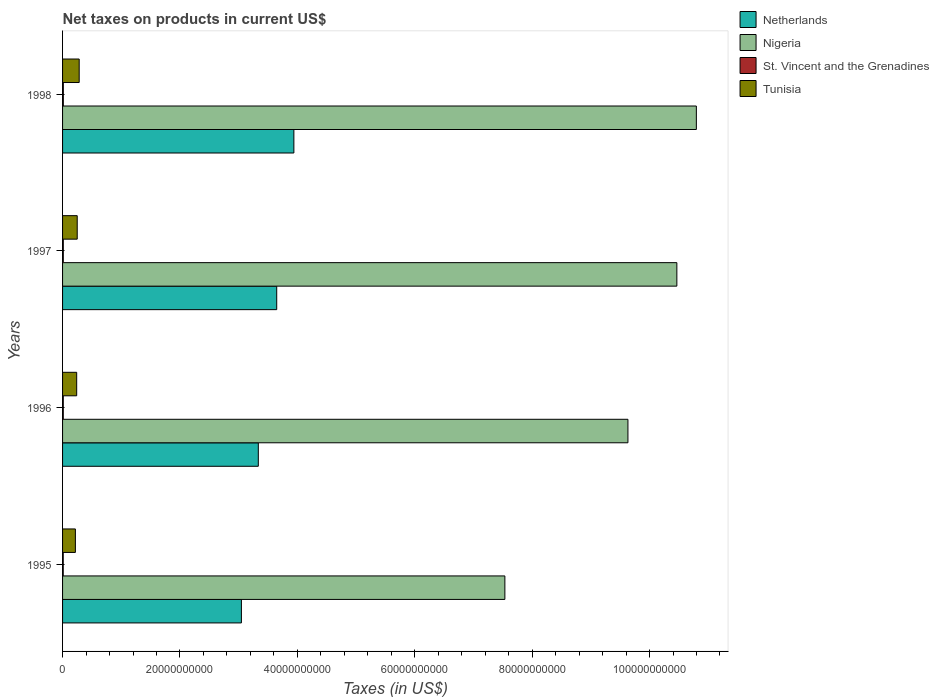How many different coloured bars are there?
Ensure brevity in your answer.  4. How many groups of bars are there?
Ensure brevity in your answer.  4. Are the number of bars per tick equal to the number of legend labels?
Provide a short and direct response. Yes. Are the number of bars on each tick of the Y-axis equal?
Your answer should be very brief. Yes. How many bars are there on the 1st tick from the bottom?
Your answer should be very brief. 4. In how many cases, is the number of bars for a given year not equal to the number of legend labels?
Keep it short and to the point. 0. What is the net taxes on products in Tunisia in 1997?
Make the answer very short. 2.50e+09. Across all years, what is the maximum net taxes on products in St. Vincent and the Grenadines?
Provide a succinct answer. 1.31e+08. Across all years, what is the minimum net taxes on products in Nigeria?
Offer a terse response. 7.54e+1. What is the total net taxes on products in Netherlands in the graph?
Keep it short and to the point. 1.40e+11. What is the difference between the net taxes on products in Tunisia in 1996 and that in 1997?
Keep it short and to the point. -9.08e+07. What is the difference between the net taxes on products in Nigeria in 1995 and the net taxes on products in St. Vincent and the Grenadines in 1997?
Your response must be concise. 7.52e+1. What is the average net taxes on products in Nigeria per year?
Make the answer very short. 9.61e+1. In the year 1995, what is the difference between the net taxes on products in Nigeria and net taxes on products in St. Vincent and the Grenadines?
Make the answer very short. 7.52e+1. In how many years, is the net taxes on products in St. Vincent and the Grenadines greater than 40000000000 US$?
Provide a short and direct response. 0. What is the ratio of the net taxes on products in Tunisia in 1995 to that in 1996?
Make the answer very short. 0.91. What is the difference between the highest and the second highest net taxes on products in Tunisia?
Your answer should be compact. 3.37e+08. What is the difference between the highest and the lowest net taxes on products in Netherlands?
Give a very brief answer. 8.94e+09. Is the sum of the net taxes on products in Netherlands in 1995 and 1996 greater than the maximum net taxes on products in St. Vincent and the Grenadines across all years?
Provide a short and direct response. Yes. What does the 1st bar from the top in 1997 represents?
Make the answer very short. Tunisia. What does the 3rd bar from the bottom in 1998 represents?
Keep it short and to the point. St. Vincent and the Grenadines. Is it the case that in every year, the sum of the net taxes on products in Nigeria and net taxes on products in Tunisia is greater than the net taxes on products in Netherlands?
Keep it short and to the point. Yes. How many bars are there?
Keep it short and to the point. 16. What is the difference between two consecutive major ticks on the X-axis?
Give a very brief answer. 2.00e+1. Are the values on the major ticks of X-axis written in scientific E-notation?
Offer a very short reply. No. Where does the legend appear in the graph?
Provide a succinct answer. Top right. How many legend labels are there?
Keep it short and to the point. 4. What is the title of the graph?
Give a very brief answer. Net taxes on products in current US$. What is the label or title of the X-axis?
Offer a very short reply. Taxes (in US$). What is the label or title of the Y-axis?
Your answer should be very brief. Years. What is the Taxes (in US$) in Netherlands in 1995?
Offer a very short reply. 3.05e+1. What is the Taxes (in US$) of Nigeria in 1995?
Give a very brief answer. 7.54e+1. What is the Taxes (in US$) of St. Vincent and the Grenadines in 1995?
Offer a very short reply. 1.13e+08. What is the Taxes (in US$) of Tunisia in 1995?
Your answer should be very brief. 2.19e+09. What is the Taxes (in US$) in Netherlands in 1996?
Make the answer very short. 3.33e+1. What is the Taxes (in US$) of Nigeria in 1996?
Offer a very short reply. 9.63e+1. What is the Taxes (in US$) of St. Vincent and the Grenadines in 1996?
Make the answer very short. 1.21e+08. What is the Taxes (in US$) in Tunisia in 1996?
Offer a very short reply. 2.41e+09. What is the Taxes (in US$) in Netherlands in 1997?
Your answer should be compact. 3.65e+1. What is the Taxes (in US$) in Nigeria in 1997?
Make the answer very short. 1.05e+11. What is the Taxes (in US$) of St. Vincent and the Grenadines in 1997?
Provide a short and direct response. 1.25e+08. What is the Taxes (in US$) in Tunisia in 1997?
Make the answer very short. 2.50e+09. What is the Taxes (in US$) in Netherlands in 1998?
Offer a very short reply. 3.94e+1. What is the Taxes (in US$) of Nigeria in 1998?
Offer a terse response. 1.08e+11. What is the Taxes (in US$) of St. Vincent and the Grenadines in 1998?
Provide a short and direct response. 1.31e+08. What is the Taxes (in US$) in Tunisia in 1998?
Make the answer very short. 2.83e+09. Across all years, what is the maximum Taxes (in US$) in Netherlands?
Give a very brief answer. 3.94e+1. Across all years, what is the maximum Taxes (in US$) of Nigeria?
Offer a very short reply. 1.08e+11. Across all years, what is the maximum Taxes (in US$) of St. Vincent and the Grenadines?
Provide a succinct answer. 1.31e+08. Across all years, what is the maximum Taxes (in US$) of Tunisia?
Your answer should be very brief. 2.83e+09. Across all years, what is the minimum Taxes (in US$) in Netherlands?
Keep it short and to the point. 3.05e+1. Across all years, what is the minimum Taxes (in US$) in Nigeria?
Provide a succinct answer. 7.54e+1. Across all years, what is the minimum Taxes (in US$) in St. Vincent and the Grenadines?
Provide a succinct answer. 1.13e+08. Across all years, what is the minimum Taxes (in US$) of Tunisia?
Your answer should be compact. 2.19e+09. What is the total Taxes (in US$) in Netherlands in the graph?
Keep it short and to the point. 1.40e+11. What is the total Taxes (in US$) of Nigeria in the graph?
Provide a succinct answer. 3.84e+11. What is the total Taxes (in US$) in St. Vincent and the Grenadines in the graph?
Your answer should be compact. 4.90e+08. What is the total Taxes (in US$) of Tunisia in the graph?
Keep it short and to the point. 9.92e+09. What is the difference between the Taxes (in US$) in Netherlands in 1995 and that in 1996?
Your answer should be very brief. -2.88e+09. What is the difference between the Taxes (in US$) in Nigeria in 1995 and that in 1996?
Give a very brief answer. -2.10e+1. What is the difference between the Taxes (in US$) in St. Vincent and the Grenadines in 1995 and that in 1996?
Keep it short and to the point. -7.29e+06. What is the difference between the Taxes (in US$) in Tunisia in 1995 and that in 1996?
Give a very brief answer. -2.20e+08. What is the difference between the Taxes (in US$) in Netherlands in 1995 and that in 1997?
Give a very brief answer. -6.02e+09. What is the difference between the Taxes (in US$) of Nigeria in 1995 and that in 1997?
Offer a very short reply. -2.93e+1. What is the difference between the Taxes (in US$) of St. Vincent and the Grenadines in 1995 and that in 1997?
Your answer should be very brief. -1.14e+07. What is the difference between the Taxes (in US$) in Tunisia in 1995 and that in 1997?
Your answer should be compact. -3.11e+08. What is the difference between the Taxes (in US$) in Netherlands in 1995 and that in 1998?
Keep it short and to the point. -8.94e+09. What is the difference between the Taxes (in US$) in Nigeria in 1995 and that in 1998?
Offer a terse response. -3.26e+1. What is the difference between the Taxes (in US$) of St. Vincent and the Grenadines in 1995 and that in 1998?
Make the answer very short. -1.75e+07. What is the difference between the Taxes (in US$) of Tunisia in 1995 and that in 1998?
Your answer should be compact. -6.48e+08. What is the difference between the Taxes (in US$) of Netherlands in 1996 and that in 1997?
Your answer should be compact. -3.14e+09. What is the difference between the Taxes (in US$) in Nigeria in 1996 and that in 1997?
Provide a succinct answer. -8.34e+09. What is the difference between the Taxes (in US$) of St. Vincent and the Grenadines in 1996 and that in 1997?
Provide a succinct answer. -4.08e+06. What is the difference between the Taxes (in US$) of Tunisia in 1996 and that in 1997?
Offer a terse response. -9.08e+07. What is the difference between the Taxes (in US$) of Netherlands in 1996 and that in 1998?
Keep it short and to the point. -6.06e+09. What is the difference between the Taxes (in US$) of Nigeria in 1996 and that in 1998?
Your response must be concise. -1.17e+1. What is the difference between the Taxes (in US$) of St. Vincent and the Grenadines in 1996 and that in 1998?
Your answer should be compact. -1.02e+07. What is the difference between the Taxes (in US$) of Tunisia in 1996 and that in 1998?
Your answer should be compact. -4.27e+08. What is the difference between the Taxes (in US$) in Netherlands in 1997 and that in 1998?
Make the answer very short. -2.92e+09. What is the difference between the Taxes (in US$) in Nigeria in 1997 and that in 1998?
Provide a short and direct response. -3.32e+09. What is the difference between the Taxes (in US$) in St. Vincent and the Grenadines in 1997 and that in 1998?
Your answer should be very brief. -6.16e+06. What is the difference between the Taxes (in US$) of Tunisia in 1997 and that in 1998?
Provide a short and direct response. -3.37e+08. What is the difference between the Taxes (in US$) of Netherlands in 1995 and the Taxes (in US$) of Nigeria in 1996?
Your response must be concise. -6.58e+1. What is the difference between the Taxes (in US$) of Netherlands in 1995 and the Taxes (in US$) of St. Vincent and the Grenadines in 1996?
Make the answer very short. 3.03e+1. What is the difference between the Taxes (in US$) of Netherlands in 1995 and the Taxes (in US$) of Tunisia in 1996?
Offer a very short reply. 2.81e+1. What is the difference between the Taxes (in US$) in Nigeria in 1995 and the Taxes (in US$) in St. Vincent and the Grenadines in 1996?
Give a very brief answer. 7.52e+1. What is the difference between the Taxes (in US$) in Nigeria in 1995 and the Taxes (in US$) in Tunisia in 1996?
Make the answer very short. 7.29e+1. What is the difference between the Taxes (in US$) of St. Vincent and the Grenadines in 1995 and the Taxes (in US$) of Tunisia in 1996?
Offer a terse response. -2.29e+09. What is the difference between the Taxes (in US$) of Netherlands in 1995 and the Taxes (in US$) of Nigeria in 1997?
Your response must be concise. -7.42e+1. What is the difference between the Taxes (in US$) in Netherlands in 1995 and the Taxes (in US$) in St. Vincent and the Grenadines in 1997?
Your answer should be very brief. 3.03e+1. What is the difference between the Taxes (in US$) in Netherlands in 1995 and the Taxes (in US$) in Tunisia in 1997?
Keep it short and to the point. 2.80e+1. What is the difference between the Taxes (in US$) of Nigeria in 1995 and the Taxes (in US$) of St. Vincent and the Grenadines in 1997?
Your response must be concise. 7.52e+1. What is the difference between the Taxes (in US$) in Nigeria in 1995 and the Taxes (in US$) in Tunisia in 1997?
Offer a very short reply. 7.29e+1. What is the difference between the Taxes (in US$) in St. Vincent and the Grenadines in 1995 and the Taxes (in US$) in Tunisia in 1997?
Your answer should be compact. -2.38e+09. What is the difference between the Taxes (in US$) of Netherlands in 1995 and the Taxes (in US$) of Nigeria in 1998?
Your answer should be very brief. -7.75e+1. What is the difference between the Taxes (in US$) in Netherlands in 1995 and the Taxes (in US$) in St. Vincent and the Grenadines in 1998?
Your response must be concise. 3.03e+1. What is the difference between the Taxes (in US$) of Netherlands in 1995 and the Taxes (in US$) of Tunisia in 1998?
Provide a succinct answer. 2.76e+1. What is the difference between the Taxes (in US$) of Nigeria in 1995 and the Taxes (in US$) of St. Vincent and the Grenadines in 1998?
Give a very brief answer. 7.52e+1. What is the difference between the Taxes (in US$) in Nigeria in 1995 and the Taxes (in US$) in Tunisia in 1998?
Your answer should be compact. 7.25e+1. What is the difference between the Taxes (in US$) of St. Vincent and the Grenadines in 1995 and the Taxes (in US$) of Tunisia in 1998?
Provide a short and direct response. -2.72e+09. What is the difference between the Taxes (in US$) in Netherlands in 1996 and the Taxes (in US$) in Nigeria in 1997?
Offer a terse response. -7.13e+1. What is the difference between the Taxes (in US$) of Netherlands in 1996 and the Taxes (in US$) of St. Vincent and the Grenadines in 1997?
Make the answer very short. 3.32e+1. What is the difference between the Taxes (in US$) of Netherlands in 1996 and the Taxes (in US$) of Tunisia in 1997?
Offer a very short reply. 3.09e+1. What is the difference between the Taxes (in US$) of Nigeria in 1996 and the Taxes (in US$) of St. Vincent and the Grenadines in 1997?
Ensure brevity in your answer.  9.62e+1. What is the difference between the Taxes (in US$) in Nigeria in 1996 and the Taxes (in US$) in Tunisia in 1997?
Your response must be concise. 9.38e+1. What is the difference between the Taxes (in US$) in St. Vincent and the Grenadines in 1996 and the Taxes (in US$) in Tunisia in 1997?
Make the answer very short. -2.38e+09. What is the difference between the Taxes (in US$) of Netherlands in 1996 and the Taxes (in US$) of Nigeria in 1998?
Keep it short and to the point. -7.46e+1. What is the difference between the Taxes (in US$) of Netherlands in 1996 and the Taxes (in US$) of St. Vincent and the Grenadines in 1998?
Ensure brevity in your answer.  3.32e+1. What is the difference between the Taxes (in US$) of Netherlands in 1996 and the Taxes (in US$) of Tunisia in 1998?
Make the answer very short. 3.05e+1. What is the difference between the Taxes (in US$) of Nigeria in 1996 and the Taxes (in US$) of St. Vincent and the Grenadines in 1998?
Keep it short and to the point. 9.62e+1. What is the difference between the Taxes (in US$) of Nigeria in 1996 and the Taxes (in US$) of Tunisia in 1998?
Offer a terse response. 9.35e+1. What is the difference between the Taxes (in US$) in St. Vincent and the Grenadines in 1996 and the Taxes (in US$) in Tunisia in 1998?
Your answer should be very brief. -2.71e+09. What is the difference between the Taxes (in US$) in Netherlands in 1997 and the Taxes (in US$) in Nigeria in 1998?
Provide a succinct answer. -7.15e+1. What is the difference between the Taxes (in US$) of Netherlands in 1997 and the Taxes (in US$) of St. Vincent and the Grenadines in 1998?
Give a very brief answer. 3.64e+1. What is the difference between the Taxes (in US$) in Netherlands in 1997 and the Taxes (in US$) in Tunisia in 1998?
Offer a terse response. 3.37e+1. What is the difference between the Taxes (in US$) of Nigeria in 1997 and the Taxes (in US$) of St. Vincent and the Grenadines in 1998?
Make the answer very short. 1.05e+11. What is the difference between the Taxes (in US$) of Nigeria in 1997 and the Taxes (in US$) of Tunisia in 1998?
Provide a short and direct response. 1.02e+11. What is the difference between the Taxes (in US$) in St. Vincent and the Grenadines in 1997 and the Taxes (in US$) in Tunisia in 1998?
Provide a short and direct response. -2.71e+09. What is the average Taxes (in US$) of Netherlands per year?
Offer a very short reply. 3.49e+1. What is the average Taxes (in US$) in Nigeria per year?
Your answer should be very brief. 9.61e+1. What is the average Taxes (in US$) of St. Vincent and the Grenadines per year?
Ensure brevity in your answer.  1.22e+08. What is the average Taxes (in US$) of Tunisia per year?
Make the answer very short. 2.48e+09. In the year 1995, what is the difference between the Taxes (in US$) of Netherlands and Taxes (in US$) of Nigeria?
Ensure brevity in your answer.  -4.49e+1. In the year 1995, what is the difference between the Taxes (in US$) in Netherlands and Taxes (in US$) in St. Vincent and the Grenadines?
Ensure brevity in your answer.  3.04e+1. In the year 1995, what is the difference between the Taxes (in US$) in Netherlands and Taxes (in US$) in Tunisia?
Keep it short and to the point. 2.83e+1. In the year 1995, what is the difference between the Taxes (in US$) in Nigeria and Taxes (in US$) in St. Vincent and the Grenadines?
Provide a short and direct response. 7.52e+1. In the year 1995, what is the difference between the Taxes (in US$) in Nigeria and Taxes (in US$) in Tunisia?
Keep it short and to the point. 7.32e+1. In the year 1995, what is the difference between the Taxes (in US$) in St. Vincent and the Grenadines and Taxes (in US$) in Tunisia?
Your answer should be compact. -2.07e+09. In the year 1996, what is the difference between the Taxes (in US$) in Netherlands and Taxes (in US$) in Nigeria?
Keep it short and to the point. -6.30e+1. In the year 1996, what is the difference between the Taxes (in US$) of Netherlands and Taxes (in US$) of St. Vincent and the Grenadines?
Offer a very short reply. 3.32e+1. In the year 1996, what is the difference between the Taxes (in US$) of Netherlands and Taxes (in US$) of Tunisia?
Ensure brevity in your answer.  3.09e+1. In the year 1996, what is the difference between the Taxes (in US$) in Nigeria and Taxes (in US$) in St. Vincent and the Grenadines?
Provide a short and direct response. 9.62e+1. In the year 1996, what is the difference between the Taxes (in US$) of Nigeria and Taxes (in US$) of Tunisia?
Provide a succinct answer. 9.39e+1. In the year 1996, what is the difference between the Taxes (in US$) of St. Vincent and the Grenadines and Taxes (in US$) of Tunisia?
Make the answer very short. -2.28e+09. In the year 1997, what is the difference between the Taxes (in US$) in Netherlands and Taxes (in US$) in Nigeria?
Your response must be concise. -6.82e+1. In the year 1997, what is the difference between the Taxes (in US$) of Netherlands and Taxes (in US$) of St. Vincent and the Grenadines?
Make the answer very short. 3.64e+1. In the year 1997, what is the difference between the Taxes (in US$) of Netherlands and Taxes (in US$) of Tunisia?
Ensure brevity in your answer.  3.40e+1. In the year 1997, what is the difference between the Taxes (in US$) of Nigeria and Taxes (in US$) of St. Vincent and the Grenadines?
Offer a terse response. 1.05e+11. In the year 1997, what is the difference between the Taxes (in US$) of Nigeria and Taxes (in US$) of Tunisia?
Your answer should be compact. 1.02e+11. In the year 1997, what is the difference between the Taxes (in US$) in St. Vincent and the Grenadines and Taxes (in US$) in Tunisia?
Ensure brevity in your answer.  -2.37e+09. In the year 1998, what is the difference between the Taxes (in US$) of Netherlands and Taxes (in US$) of Nigeria?
Keep it short and to the point. -6.86e+1. In the year 1998, what is the difference between the Taxes (in US$) in Netherlands and Taxes (in US$) in St. Vincent and the Grenadines?
Offer a terse response. 3.93e+1. In the year 1998, what is the difference between the Taxes (in US$) of Netherlands and Taxes (in US$) of Tunisia?
Offer a terse response. 3.66e+1. In the year 1998, what is the difference between the Taxes (in US$) of Nigeria and Taxes (in US$) of St. Vincent and the Grenadines?
Give a very brief answer. 1.08e+11. In the year 1998, what is the difference between the Taxes (in US$) in Nigeria and Taxes (in US$) in Tunisia?
Your response must be concise. 1.05e+11. In the year 1998, what is the difference between the Taxes (in US$) in St. Vincent and the Grenadines and Taxes (in US$) in Tunisia?
Your answer should be very brief. -2.70e+09. What is the ratio of the Taxes (in US$) of Netherlands in 1995 to that in 1996?
Offer a very short reply. 0.91. What is the ratio of the Taxes (in US$) of Nigeria in 1995 to that in 1996?
Offer a very short reply. 0.78. What is the ratio of the Taxes (in US$) of St. Vincent and the Grenadines in 1995 to that in 1996?
Offer a very short reply. 0.94. What is the ratio of the Taxes (in US$) of Tunisia in 1995 to that in 1996?
Make the answer very short. 0.91. What is the ratio of the Taxes (in US$) of Netherlands in 1995 to that in 1997?
Make the answer very short. 0.84. What is the ratio of the Taxes (in US$) in Nigeria in 1995 to that in 1997?
Offer a very short reply. 0.72. What is the ratio of the Taxes (in US$) in St. Vincent and the Grenadines in 1995 to that in 1997?
Provide a succinct answer. 0.91. What is the ratio of the Taxes (in US$) in Tunisia in 1995 to that in 1997?
Give a very brief answer. 0.88. What is the ratio of the Taxes (in US$) in Netherlands in 1995 to that in 1998?
Provide a short and direct response. 0.77. What is the ratio of the Taxes (in US$) in Nigeria in 1995 to that in 1998?
Ensure brevity in your answer.  0.7. What is the ratio of the Taxes (in US$) in St. Vincent and the Grenadines in 1995 to that in 1998?
Ensure brevity in your answer.  0.87. What is the ratio of the Taxes (in US$) in Tunisia in 1995 to that in 1998?
Your answer should be very brief. 0.77. What is the ratio of the Taxes (in US$) of Netherlands in 1996 to that in 1997?
Ensure brevity in your answer.  0.91. What is the ratio of the Taxes (in US$) in Nigeria in 1996 to that in 1997?
Offer a terse response. 0.92. What is the ratio of the Taxes (in US$) of St. Vincent and the Grenadines in 1996 to that in 1997?
Offer a terse response. 0.97. What is the ratio of the Taxes (in US$) of Tunisia in 1996 to that in 1997?
Your answer should be compact. 0.96. What is the ratio of the Taxes (in US$) in Netherlands in 1996 to that in 1998?
Ensure brevity in your answer.  0.85. What is the ratio of the Taxes (in US$) of Nigeria in 1996 to that in 1998?
Your response must be concise. 0.89. What is the ratio of the Taxes (in US$) in St. Vincent and the Grenadines in 1996 to that in 1998?
Provide a succinct answer. 0.92. What is the ratio of the Taxes (in US$) of Tunisia in 1996 to that in 1998?
Offer a terse response. 0.85. What is the ratio of the Taxes (in US$) in Netherlands in 1997 to that in 1998?
Keep it short and to the point. 0.93. What is the ratio of the Taxes (in US$) of Nigeria in 1997 to that in 1998?
Keep it short and to the point. 0.97. What is the ratio of the Taxes (in US$) of St. Vincent and the Grenadines in 1997 to that in 1998?
Keep it short and to the point. 0.95. What is the ratio of the Taxes (in US$) in Tunisia in 1997 to that in 1998?
Keep it short and to the point. 0.88. What is the difference between the highest and the second highest Taxes (in US$) of Netherlands?
Offer a terse response. 2.92e+09. What is the difference between the highest and the second highest Taxes (in US$) in Nigeria?
Give a very brief answer. 3.32e+09. What is the difference between the highest and the second highest Taxes (in US$) in St. Vincent and the Grenadines?
Offer a terse response. 6.16e+06. What is the difference between the highest and the second highest Taxes (in US$) of Tunisia?
Offer a very short reply. 3.37e+08. What is the difference between the highest and the lowest Taxes (in US$) in Netherlands?
Make the answer very short. 8.94e+09. What is the difference between the highest and the lowest Taxes (in US$) in Nigeria?
Your response must be concise. 3.26e+1. What is the difference between the highest and the lowest Taxes (in US$) in St. Vincent and the Grenadines?
Your answer should be very brief. 1.75e+07. What is the difference between the highest and the lowest Taxes (in US$) of Tunisia?
Make the answer very short. 6.48e+08. 